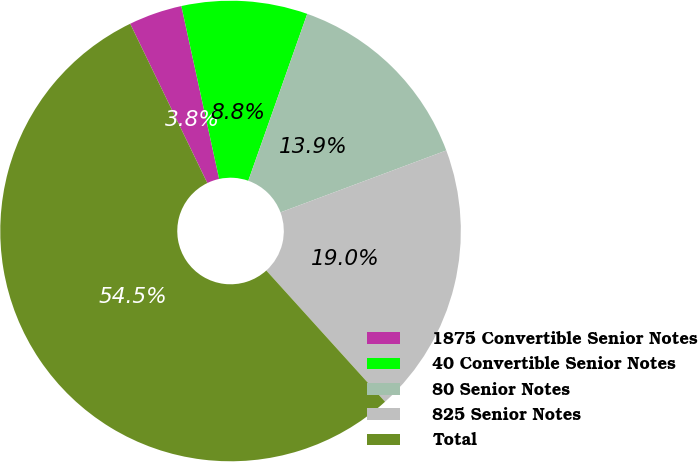<chart> <loc_0><loc_0><loc_500><loc_500><pie_chart><fcel>1875 Convertible Senior Notes<fcel>40 Convertible Senior Notes<fcel>80 Senior Notes<fcel>825 Senior Notes<fcel>Total<nl><fcel>3.75%<fcel>8.83%<fcel>13.91%<fcel>18.98%<fcel>54.53%<nl></chart> 